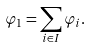Convert formula to latex. <formula><loc_0><loc_0><loc_500><loc_500>\varphi _ { 1 } = \sum _ { i \in { I } } \varphi _ { i } .</formula> 